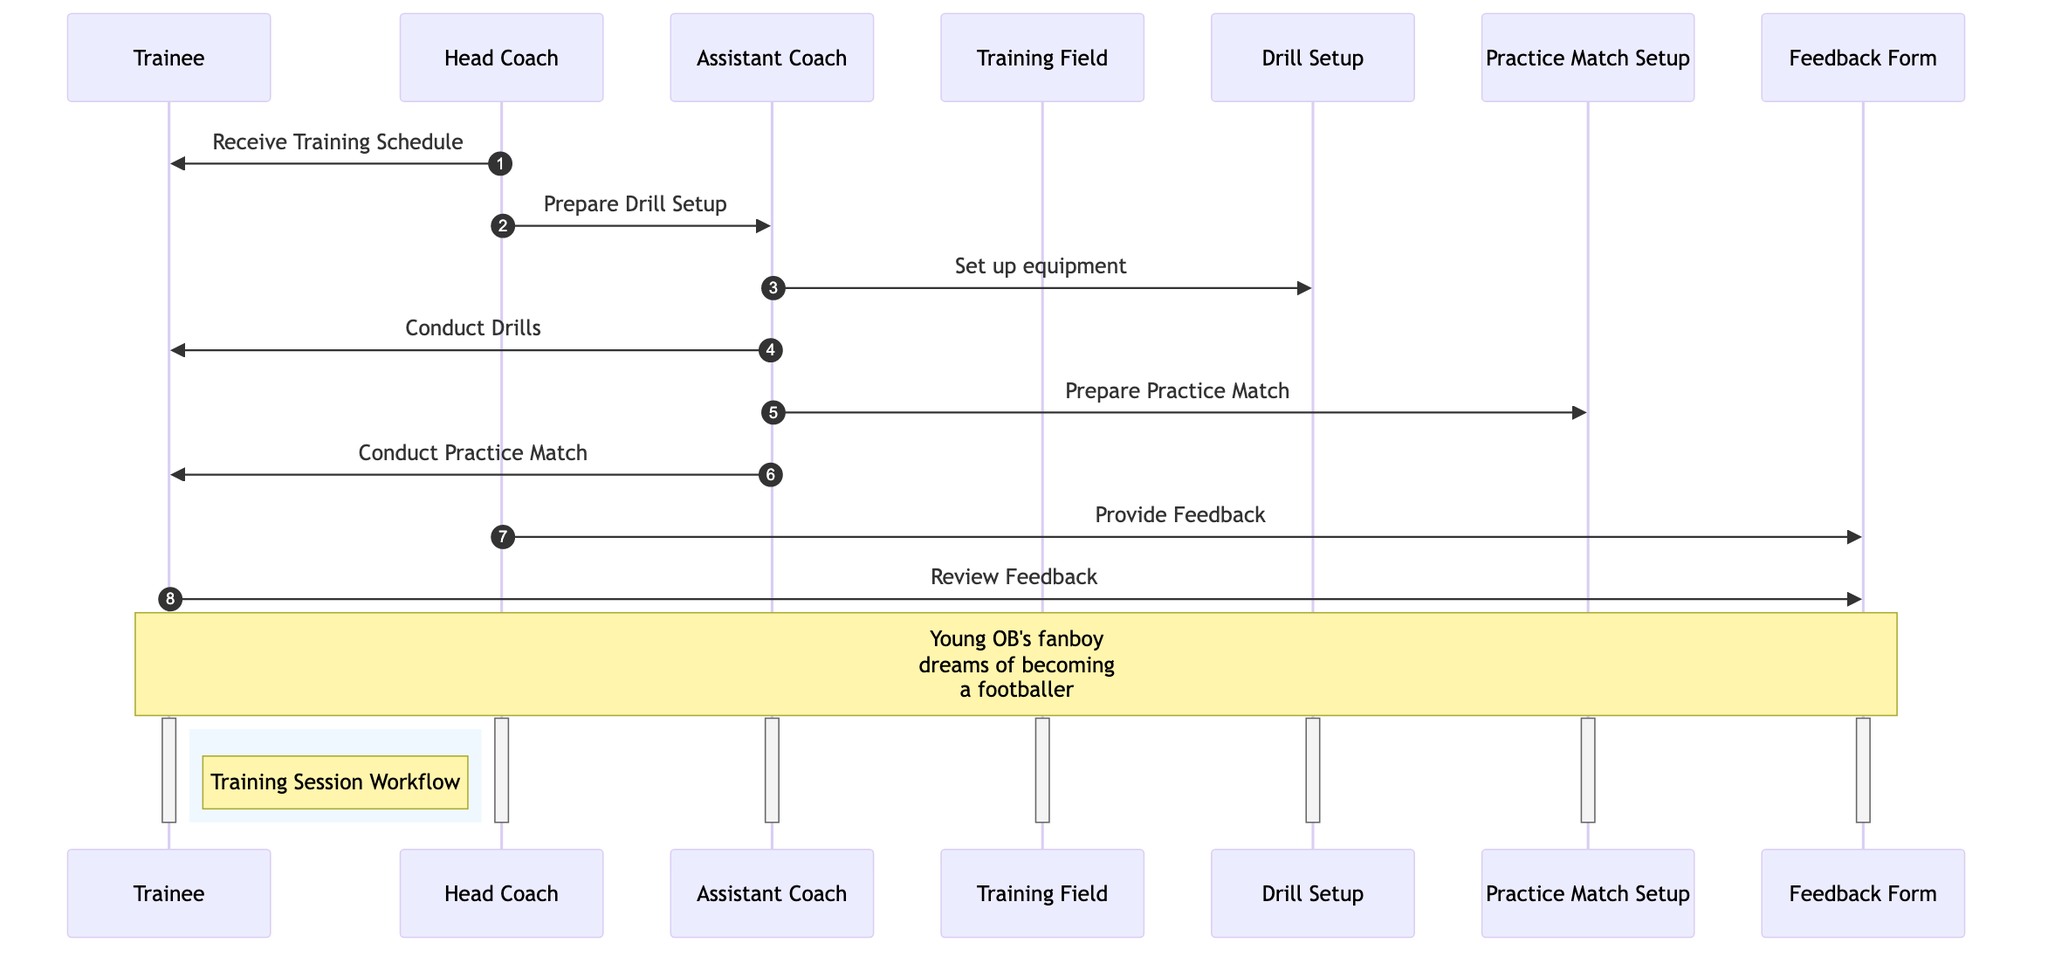What does the Head Coach provide to the Trainee? The diagram shows that the Head Coach sends a "Receive Training Schedule" to the Trainee. This indicates that the Head Coach provides the structural information needed for the training session.
Answer: Training Schedule Who sets up the drill equipment? According to the diagram, the Head Coach directs the Assistant Coach to "Prepare Drill Setup," which means the Assistant Coach is responsible for setting up the drill equipment.
Answer: Assistant Coach How many objects are involved in the training session workflow? Upon examining the diagram, there are four objects labeled: Training Field, Drill Setup, Practice Match Setup, and Feedback Form. Therefore, the total count of objects involved is four.
Answer: 4 What action does the Assistant Coach take after preparing the drills? The Assistant Coach first prepares the drill setup, then conducts the drills according to the sequence indicated in the diagram. This shows a progression from preparation to active engagement.
Answer: Conduct Drills Which form does the Head Coach complete based on the trainee's performance? The Head Coach completes a "Feedback Form" as indicated in the diagram, which serves as the document for providing feedback regarding the trainee's performance during drills and practice matches.
Answer: Feedback Form What is the final action taken by the Trainee in the workflow? The final action performed by the Trainee, as indicated in the diagram, is to "Review Feedback," where they reflect on the feedback provided by the Head Coach to identify areas needing improvement.
Answer: Review Feedback What role does the Assistant Coach have during the practice match? During the practice match, the Assistant Coach's role is to officiate and monitor the match, providing real-time guidance as shown by the interaction labeled "Conduct Practice Match."
Answer: Officiates What kind of feedback does the Trainee review? The Trainee reviews feedback provided by the Head Coach in the form of a "Feedback Form," which contains notes on the trainee's performance and areas for improvement.
Answer: Performance feedback 